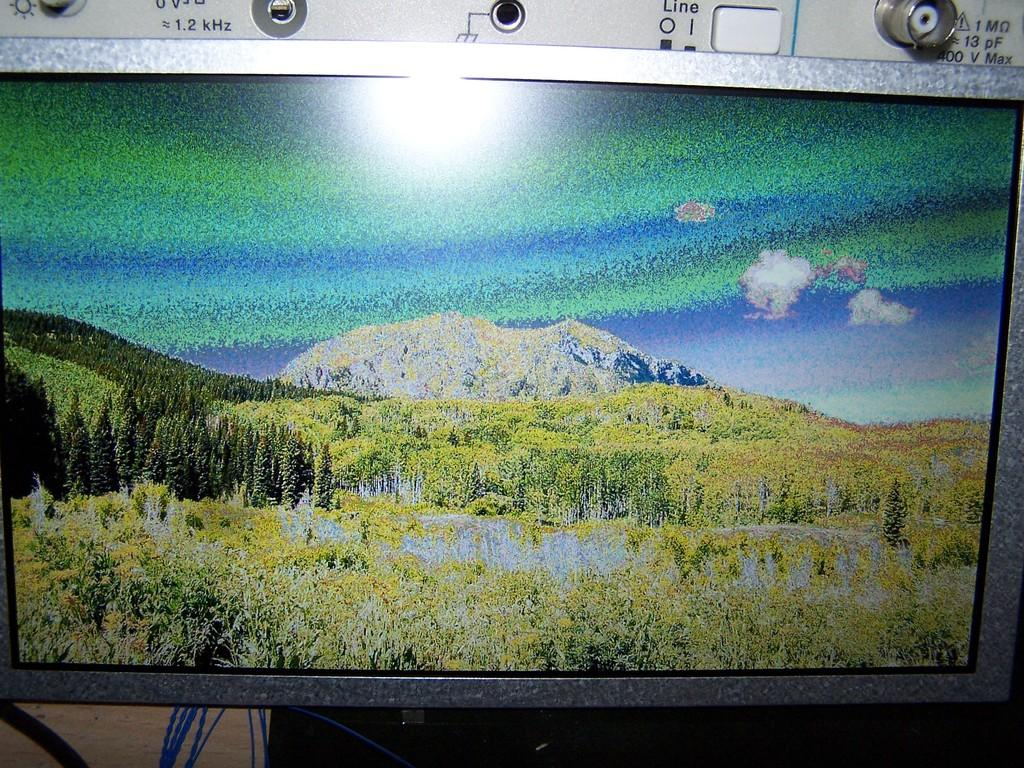<image>
Provide a brief description of the given image. Monitor used for research or scientific purposes when various plug inputs, including one with a rate at about 1.2 kHz. 